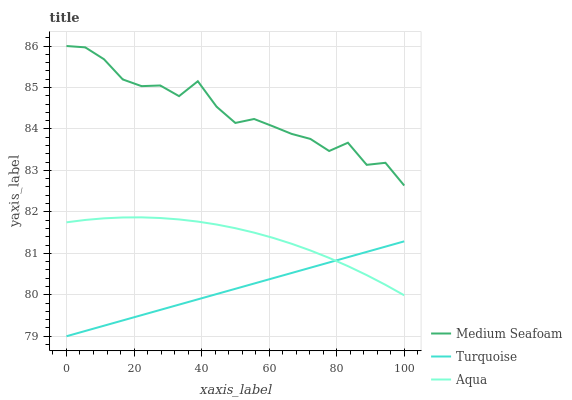Does Turquoise have the minimum area under the curve?
Answer yes or no. Yes. Does Medium Seafoam have the maximum area under the curve?
Answer yes or no. Yes. Does Aqua have the minimum area under the curve?
Answer yes or no. No. Does Aqua have the maximum area under the curve?
Answer yes or no. No. Is Turquoise the smoothest?
Answer yes or no. Yes. Is Medium Seafoam the roughest?
Answer yes or no. Yes. Is Aqua the smoothest?
Answer yes or no. No. Is Aqua the roughest?
Answer yes or no. No. Does Turquoise have the lowest value?
Answer yes or no. Yes. Does Aqua have the lowest value?
Answer yes or no. No. Does Medium Seafoam have the highest value?
Answer yes or no. Yes. Does Aqua have the highest value?
Answer yes or no. No. Is Aqua less than Medium Seafoam?
Answer yes or no. Yes. Is Medium Seafoam greater than Aqua?
Answer yes or no. Yes. Does Aqua intersect Turquoise?
Answer yes or no. Yes. Is Aqua less than Turquoise?
Answer yes or no. No. Is Aqua greater than Turquoise?
Answer yes or no. No. Does Aqua intersect Medium Seafoam?
Answer yes or no. No. 